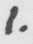Please provide the text content of this handwritten line. 1 . 